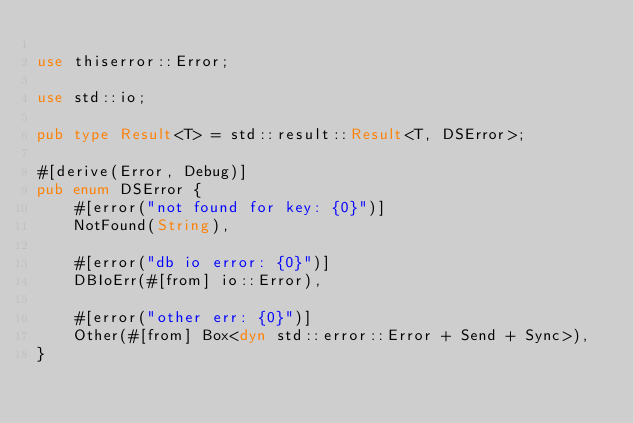<code> <loc_0><loc_0><loc_500><loc_500><_Rust_>
use thiserror::Error;

use std::io;

pub type Result<T> = std::result::Result<T, DSError>;

#[derive(Error, Debug)]
pub enum DSError {
    #[error("not found for key: {0}")]
    NotFound(String),

    #[error("db io error: {0}")]
    DBIoErr(#[from] io::Error),

    #[error("other err: {0}")]
    Other(#[from] Box<dyn std::error::Error + Send + Sync>),
}
</code> 